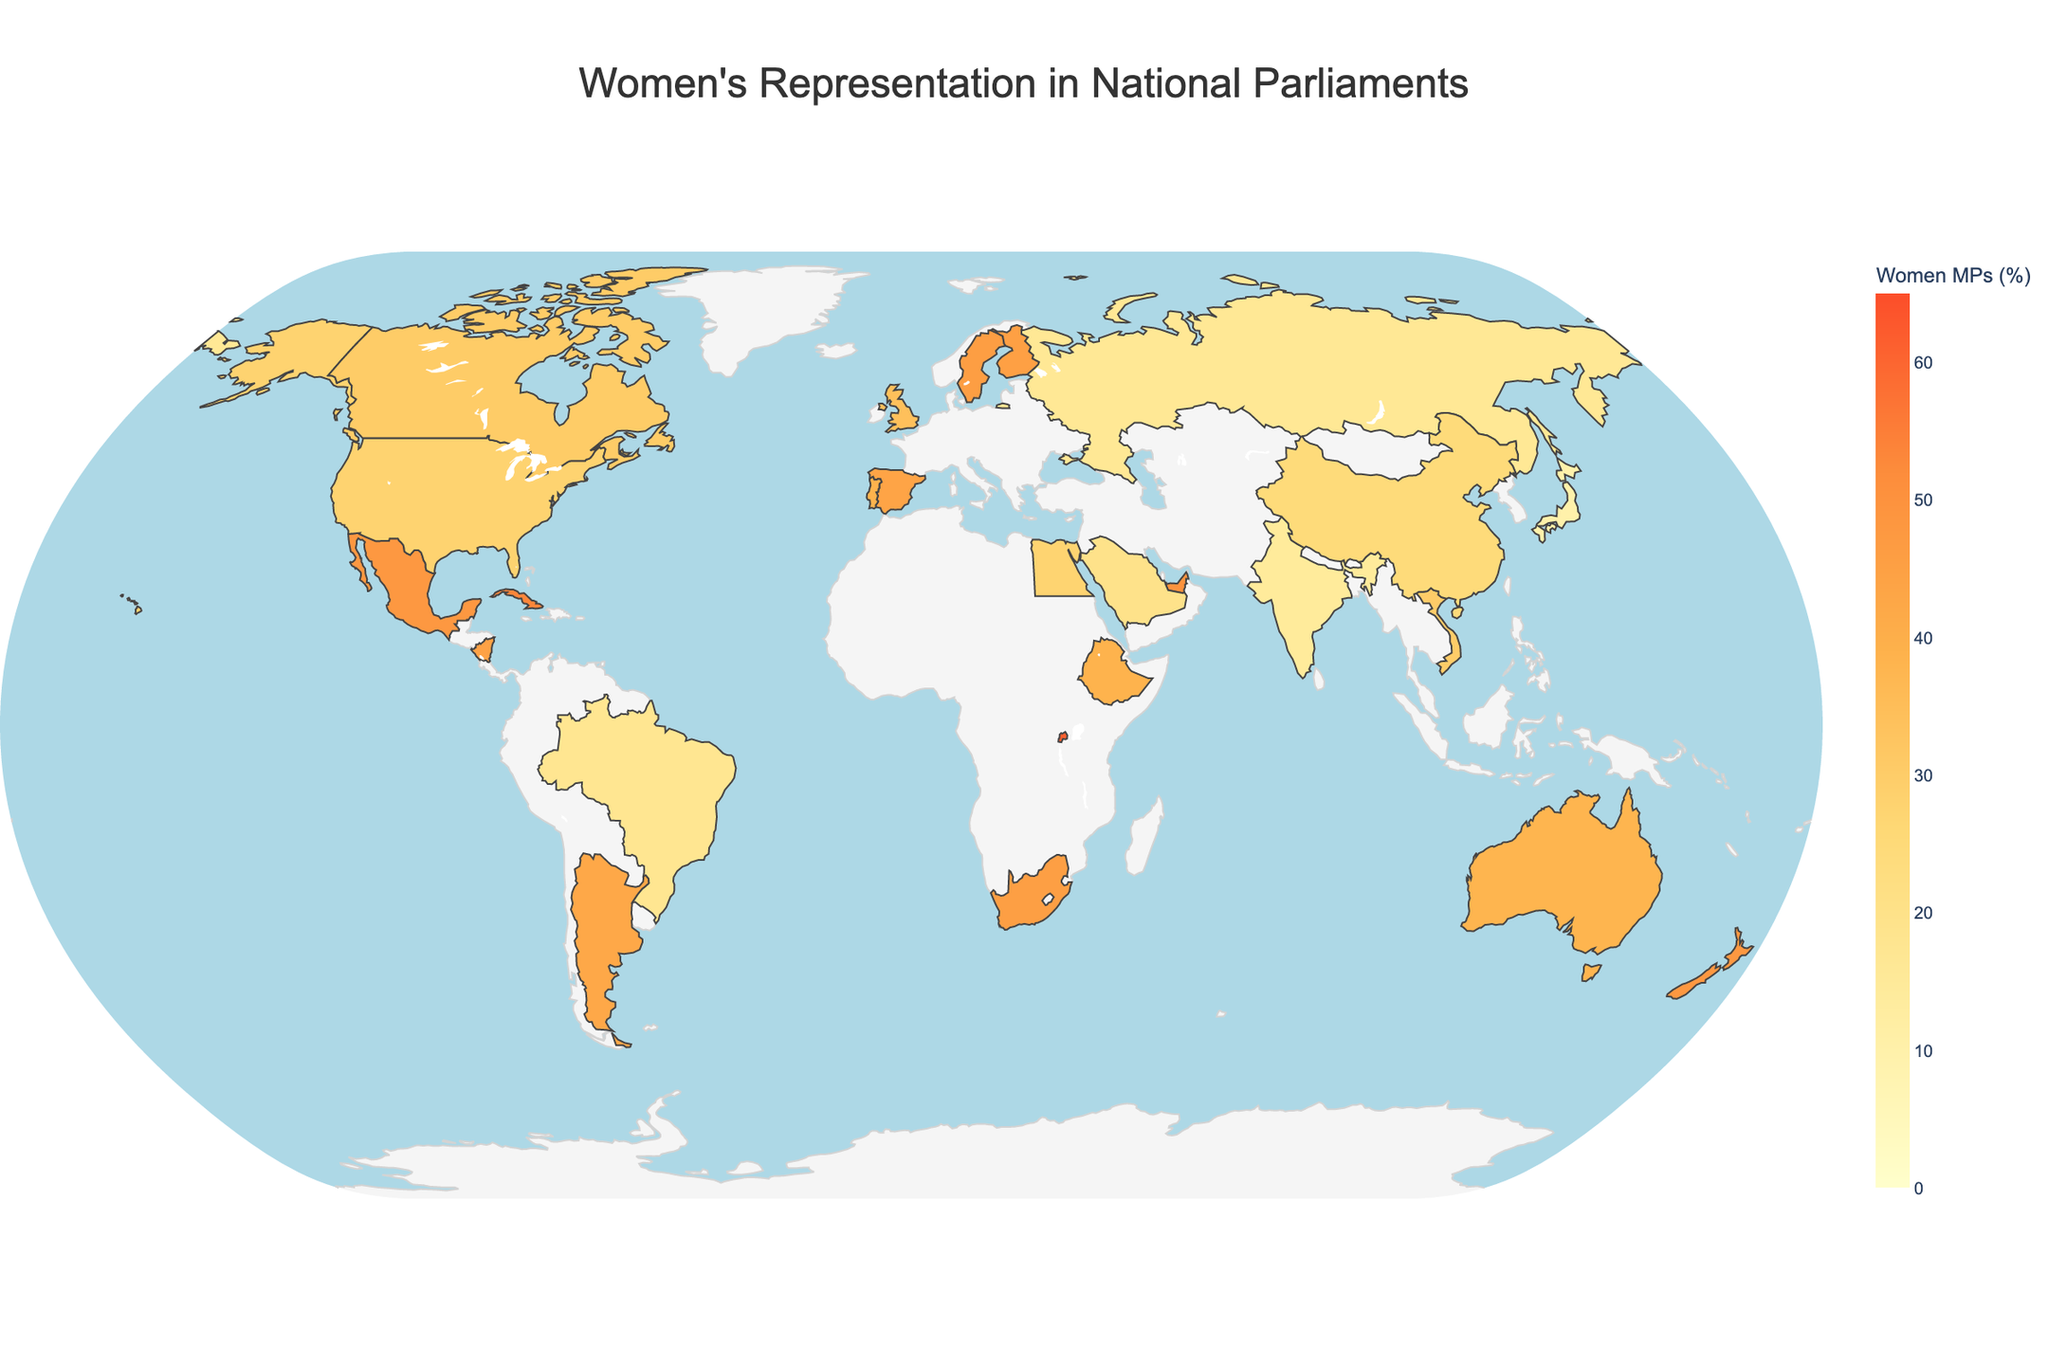What's the title of the figure? The title is usually found at the top of the chart and is designed to give a summary of the information being presented.
Answer: Women's Representation in National Parliaments Which region has the highest percentage of women MPs, according to the figure? Look for the region with the highest percentage value highlighted on the map or in the data hover-over information.
Answer: Africa (Rwanda) Comparing Europe and East Asia, which has a higher average percentage of women MPs? Calculate the average by summing the percentages of each country's women MPs in Europe and in East Asia, then divide by the number of countries in each region. For Europe: 
(46.1 + 45.5 + 44.0 + 38.7 + 34.3) / 5 = 41.72. For East Asia: 
(9.9 + 24.9) / 2 = 17.4.
41.72 > 17.4
Answer: Europe Which country in the Caribbean has a notable trend towards increasing representation of women MPs? Identify the region (Caribbean) and then look for the country within that region with the 'Increasing' trend annotation.
Answer: Cuba Which country has the lowest percentage of women MPs, and what is the trend in that country? Look at the countries with the smallest values on the color scale and identify the trend from the annotations.
Answer: Japan (9.9%, Slowly Increasing) How does the trend in New Zealand compare with the trend in Mexico? Compare the textual trends provided in the annotations for New Zealand and Mexico.
Answer: New Zealand (Stable), Mexico (Increasing) Which country in North America has fluctuating percentages of women MPs? Look for countries in North America and check their trend descriptions for 'Fluctuating'.
Answer: Canada What is the average percentage of women MPs in the Middle East, based on the figure? Calculate the average by adding up the percentages of women MPs in each Middle Eastern country and dividing by the number of countries. For the Middle East: (19.9 + 50.0) / 2 = 34.95
Answer: 34.95 Identify an outlier country in terms of women MPs representation and explain why it stands out. Look for a country with an exceptionally high or low percentage compared to regions' averages and other countries. For example, Rwanda has a very high percentage (61.3%), which stands out in comparison to other countries.
Answer: Rwanda (61.3%) 